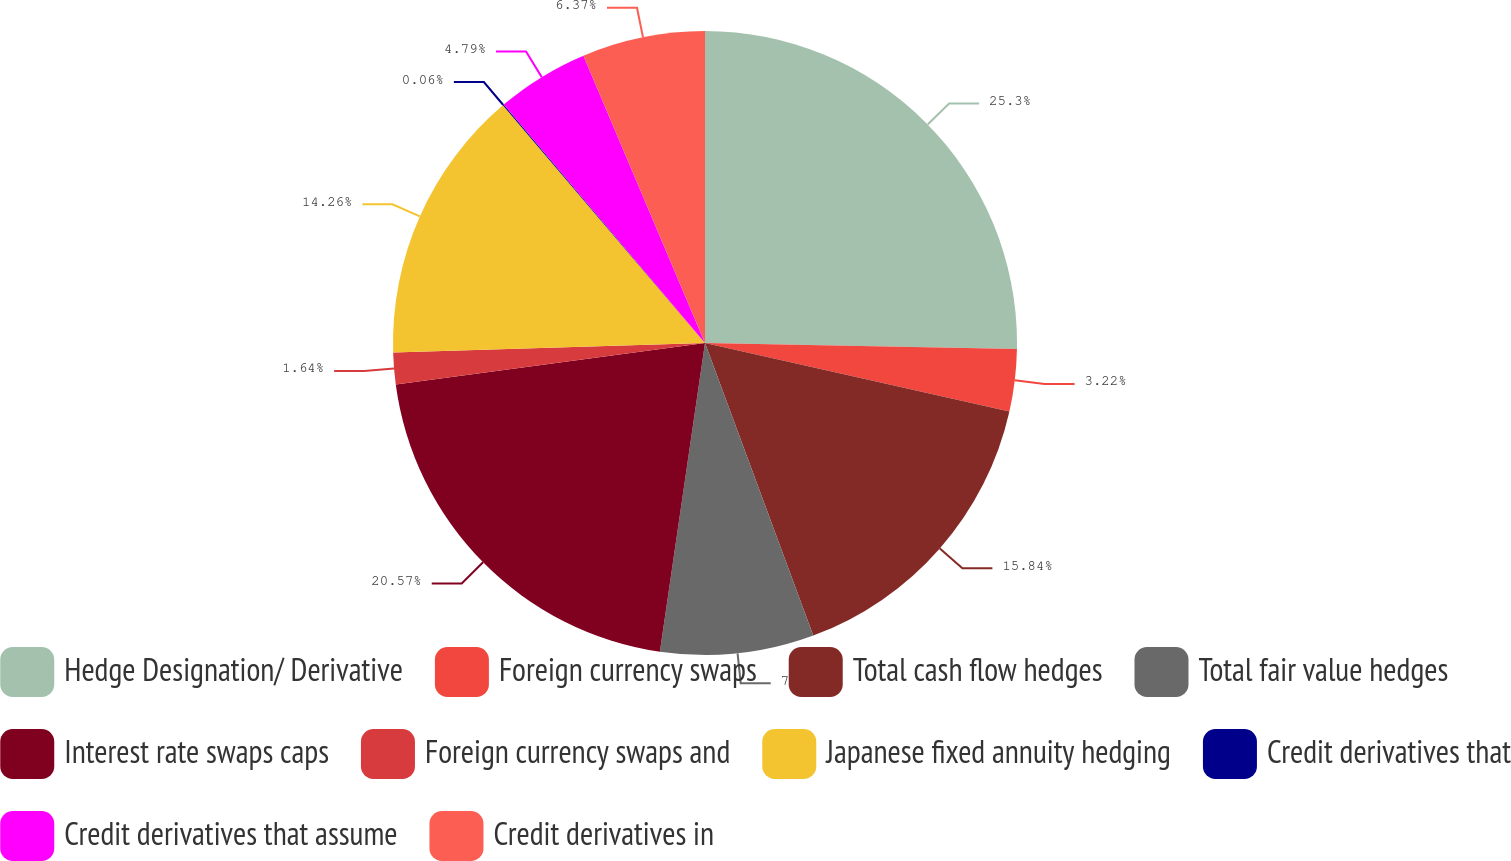Convert chart to OTSL. <chart><loc_0><loc_0><loc_500><loc_500><pie_chart><fcel>Hedge Designation/ Derivative<fcel>Foreign currency swaps<fcel>Total cash flow hedges<fcel>Total fair value hedges<fcel>Interest rate swaps caps<fcel>Foreign currency swaps and<fcel>Japanese fixed annuity hedging<fcel>Credit derivatives that<fcel>Credit derivatives that assume<fcel>Credit derivatives in<nl><fcel>25.3%<fcel>3.22%<fcel>15.84%<fcel>7.95%<fcel>20.57%<fcel>1.64%<fcel>14.26%<fcel>0.06%<fcel>4.79%<fcel>6.37%<nl></chart> 